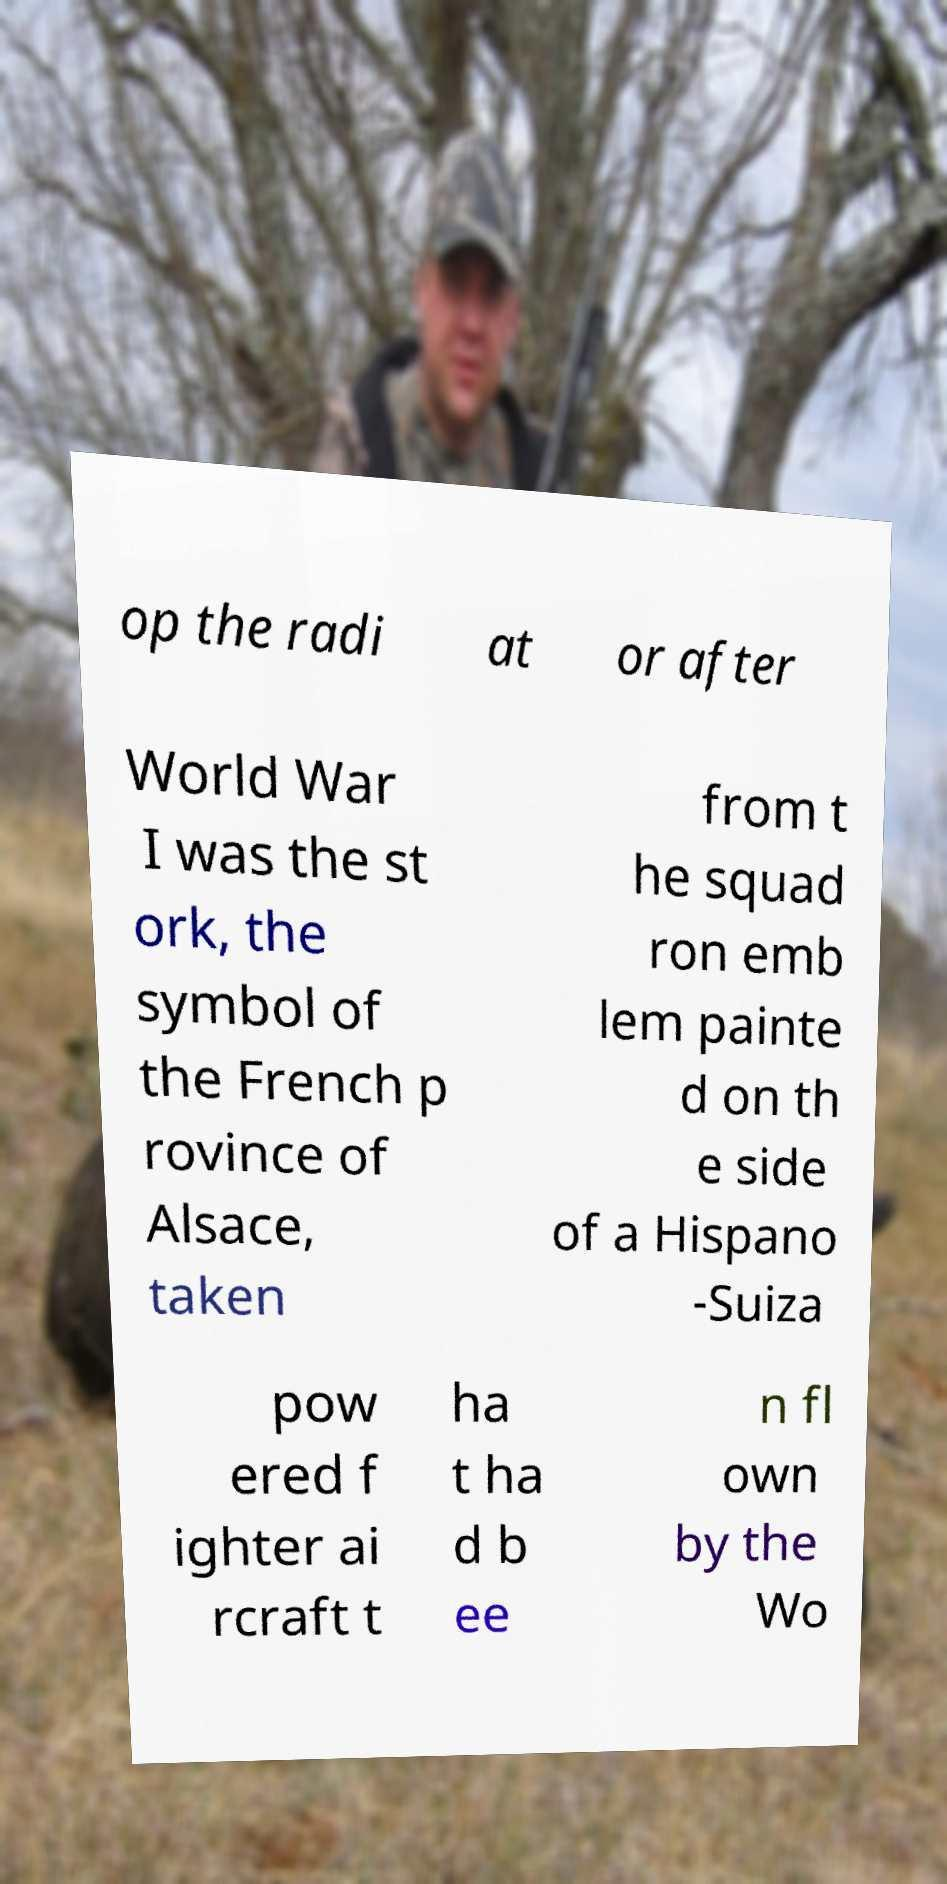What messages or text are displayed in this image? I need them in a readable, typed format. op the radi at or after World War I was the st ork, the symbol of the French p rovince of Alsace, taken from t he squad ron emb lem painte d on th e side of a Hispano -Suiza pow ered f ighter ai rcraft t ha t ha d b ee n fl own by the Wo 